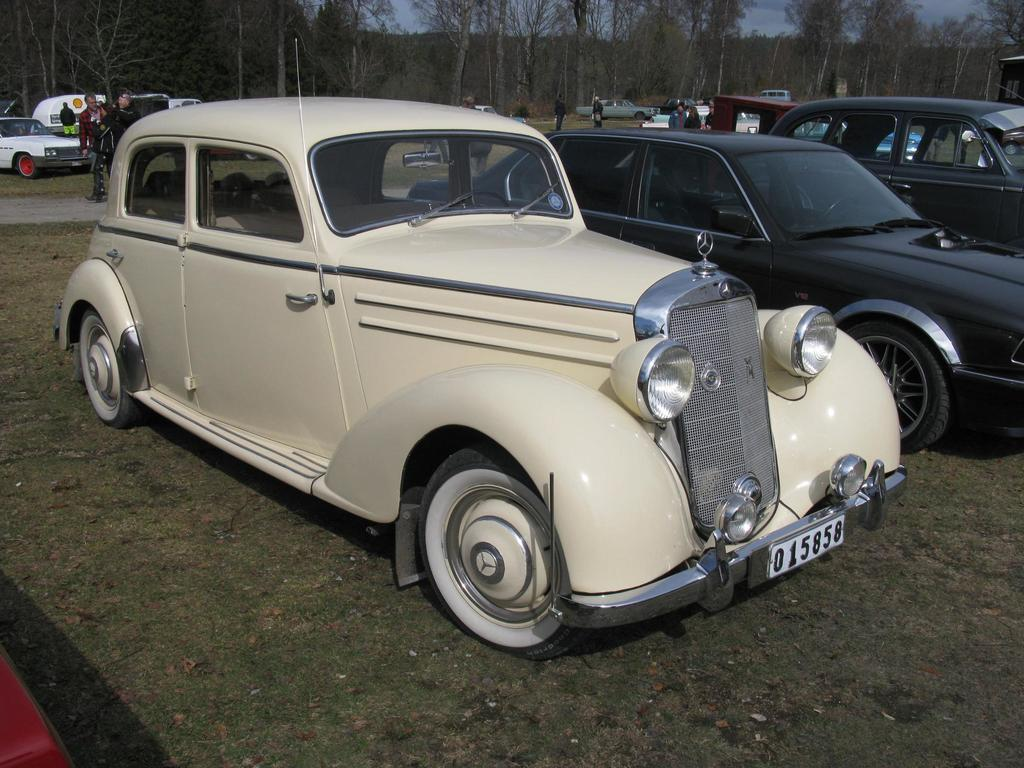What can be seen in the foreground of the picture? There are cars and a road in the foreground of the picture. What is located in the middle of the picture? There are people and vehicles in the middle of the picture, along with another road. What is visible in the background of the picture? There are trees and sky visible in the background of the picture. What type of meal is being prepared in the middle of the picture? There is no meal being prepared in the middle of the picture; it features people and vehicles. What appliance is visible in the background of the picture? There is no appliance visible in the background of the picture; it features trees and sky. 